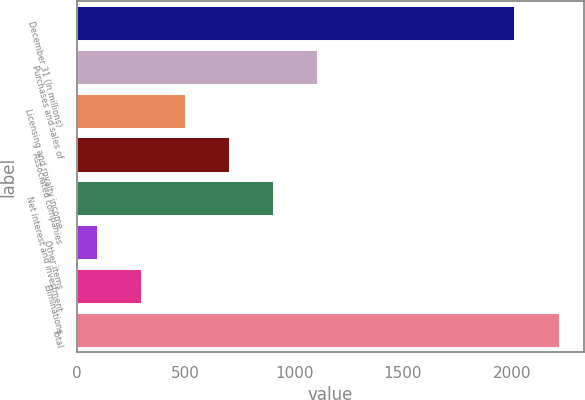Convert chart. <chart><loc_0><loc_0><loc_500><loc_500><bar_chart><fcel>December 31 (In millions)<fcel>Purchases and sales of<fcel>Licensing and royalty income<fcel>Associated companies<fcel>Net interest and investment<fcel>Other items<fcel>Eliminations<fcel>Total<nl><fcel>2017<fcel>1111<fcel>502<fcel>705<fcel>908<fcel>96<fcel>299<fcel>2220<nl></chart> 